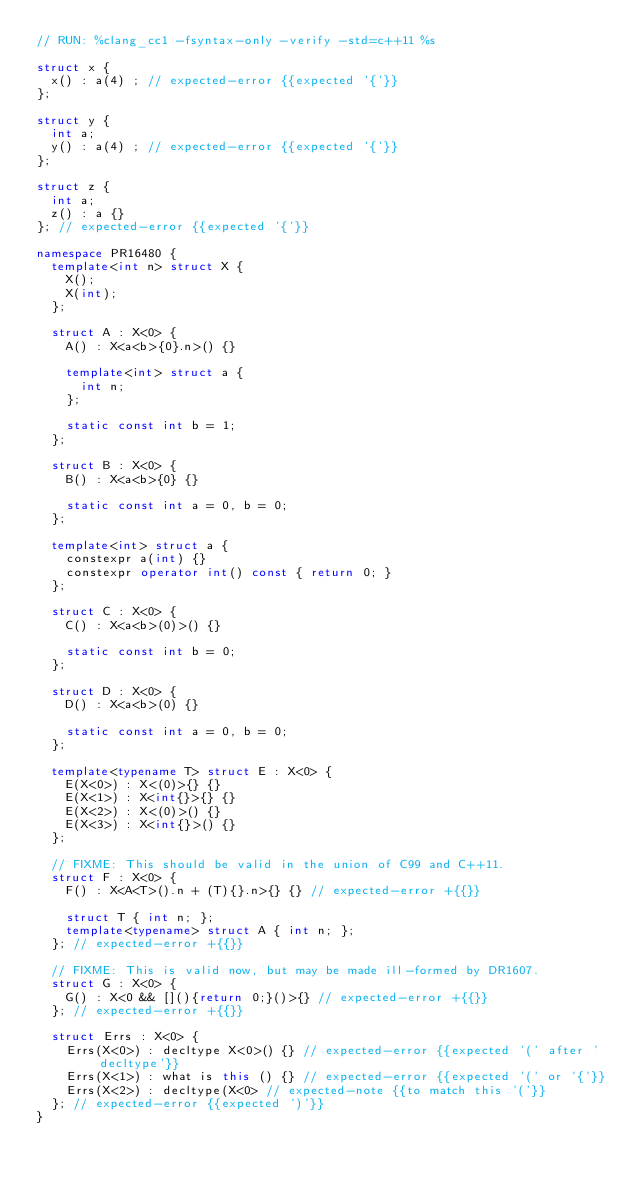Convert code to text. <code><loc_0><loc_0><loc_500><loc_500><_C++_>// RUN: %clang_cc1 -fsyntax-only -verify -std=c++11 %s

struct x {
  x() : a(4) ; // expected-error {{expected '{'}}
};

struct y {
  int a;
  y() : a(4) ; // expected-error {{expected '{'}}
};

struct z {
  int a;
  z() : a {}
}; // expected-error {{expected '{'}}

namespace PR16480 {
  template<int n> struct X {
    X();
    X(int);
  };

  struct A : X<0> {
    A() : X<a<b>{0}.n>() {}

    template<int> struct a {
      int n;
    };

    static const int b = 1;
  };

  struct B : X<0> {
    B() : X<a<b>{0} {}

    static const int a = 0, b = 0;
  };

  template<int> struct a {
    constexpr a(int) {}
    constexpr operator int() const { return 0; }
  };

  struct C : X<0> {
    C() : X<a<b>(0)>() {}

    static const int b = 0;
  };

  struct D : X<0> {
    D() : X<a<b>(0) {}

    static const int a = 0, b = 0;
  };

  template<typename T> struct E : X<0> {
    E(X<0>) : X<(0)>{} {}
    E(X<1>) : X<int{}>{} {}
    E(X<2>) : X<(0)>() {}
    E(X<3>) : X<int{}>() {}
  };

  // FIXME: This should be valid in the union of C99 and C++11.
  struct F : X<0> {
    F() : X<A<T>().n + (T){}.n>{} {} // expected-error +{{}}

    struct T { int n; };
    template<typename> struct A { int n; };
  }; // expected-error +{{}}

  // FIXME: This is valid now, but may be made ill-formed by DR1607.
  struct G : X<0> {
    G() : X<0 && [](){return 0;}()>{} // expected-error +{{}}
  }; // expected-error +{{}}

  struct Errs : X<0> {
    Errs(X<0>) : decltype X<0>() {} // expected-error {{expected '(' after 'decltype'}}
    Errs(X<1>) : what is this () {} // expected-error {{expected '(' or '{'}}
    Errs(X<2>) : decltype(X<0> // expected-note {{to match this '('}}
  }; // expected-error {{expected ')'}}
}
</code> 